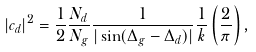<formula> <loc_0><loc_0><loc_500><loc_500>| c _ { d } | ^ { 2 } = \frac { 1 } { 2 } \frac { N _ { d } } { N _ { g } } \frac { 1 } { | \sin ( \Delta _ { g } - \Delta _ { d } ) | } \frac { 1 } { k } \left ( \frac { 2 } { \pi } \right ) ,</formula> 